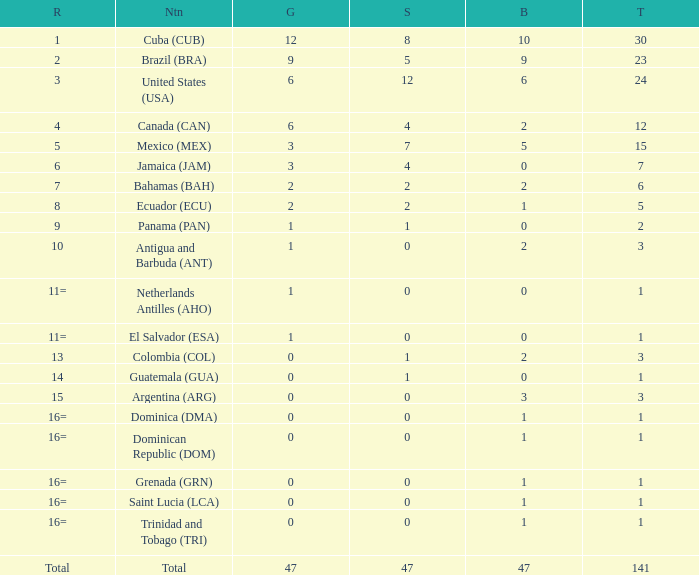Parse the full table. {'header': ['R', 'Ntn', 'G', 'S', 'B', 'T'], 'rows': [['1', 'Cuba (CUB)', '12', '8', '10', '30'], ['2', 'Brazil (BRA)', '9', '5', '9', '23'], ['3', 'United States (USA)', '6', '12', '6', '24'], ['4', 'Canada (CAN)', '6', '4', '2', '12'], ['5', 'Mexico (MEX)', '3', '7', '5', '15'], ['6', 'Jamaica (JAM)', '3', '4', '0', '7'], ['7', 'Bahamas (BAH)', '2', '2', '2', '6'], ['8', 'Ecuador (ECU)', '2', '2', '1', '5'], ['9', 'Panama (PAN)', '1', '1', '0', '2'], ['10', 'Antigua and Barbuda (ANT)', '1', '0', '2', '3'], ['11=', 'Netherlands Antilles (AHO)', '1', '0', '0', '1'], ['11=', 'El Salvador (ESA)', '1', '0', '0', '1'], ['13', 'Colombia (COL)', '0', '1', '2', '3'], ['14', 'Guatemala (GUA)', '0', '1', '0', '1'], ['15', 'Argentina (ARG)', '0', '0', '3', '3'], ['16=', 'Dominica (DMA)', '0', '0', '1', '1'], ['16=', 'Dominican Republic (DOM)', '0', '0', '1', '1'], ['16=', 'Grenada (GRN)', '0', '0', '1', '1'], ['16=', 'Saint Lucia (LCA)', '0', '0', '1', '1'], ['16=', 'Trinidad and Tobago (TRI)', '0', '0', '1', '1'], ['Total', 'Total', '47', '47', '47', '141']]} What is the total gold with a total less than 1? None. 